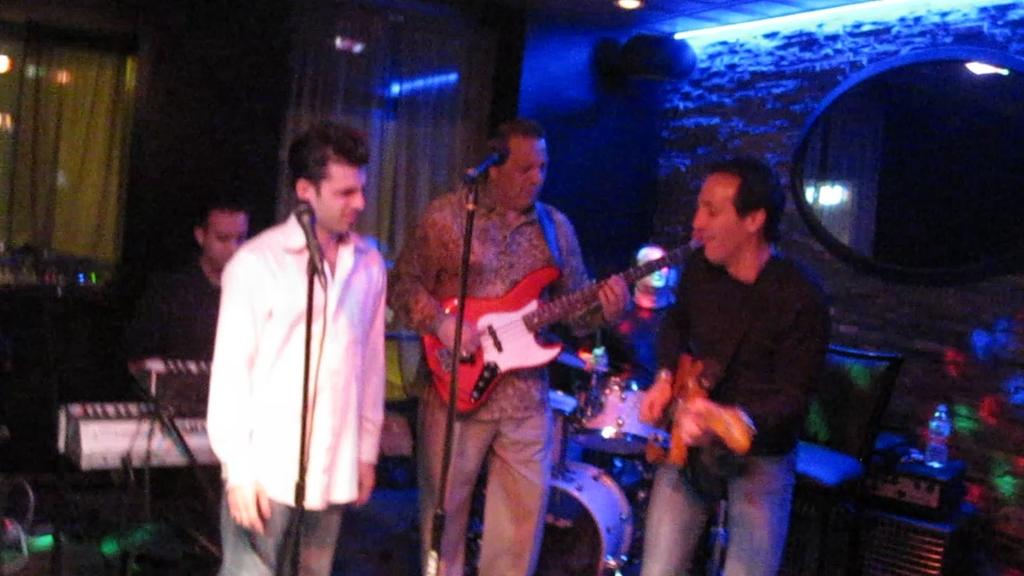How many people are present in the image? There are four people in the image. What are the people doing in the image? The people are playing musical instruments. Can you describe any equipment related to sound in the image? Yes, there is a microphone in the image. What else can be seen in the image besides the people and the microphone? There is a stand in the image. What type of clam is being used as a reward for the musicians in the image? There is no clam present in the image, nor is there any indication of a reward being given to the musicians. --- Facts: 1. There is a person holding a book in the image. 2. The book has a blue cover. 3. The person is sitting on a chair. 4. There is a table in the image. 5. The table has a lamp on it. Absurd Topics: parrot, dance, ocean Conversation: What is the person in the image holding? The person in the image is holding a book. Can you describe the book's appearance? The book has a blue cover. Where is the person sitting in the image? The person is sitting on a chair. What else can be seen in the image besides the person and the book? There is a table in the image, and a lamp is on the table. Reasoning: Let's think step by step in order to produce the conversation. We start by identifying the main subject in the image, which is the person holding a book. Then, we describe the appearance of the book, including its blue cover. Next, we mention the person's position, which is sitting on a chair. Finally, we expand the conversation to include other objects in the image, such as the table and the lamp. Absurd Question/Answer: Can you tell me how many parrots are dancing on the table in the image? There are no parrots or dancing activities present in the image. 